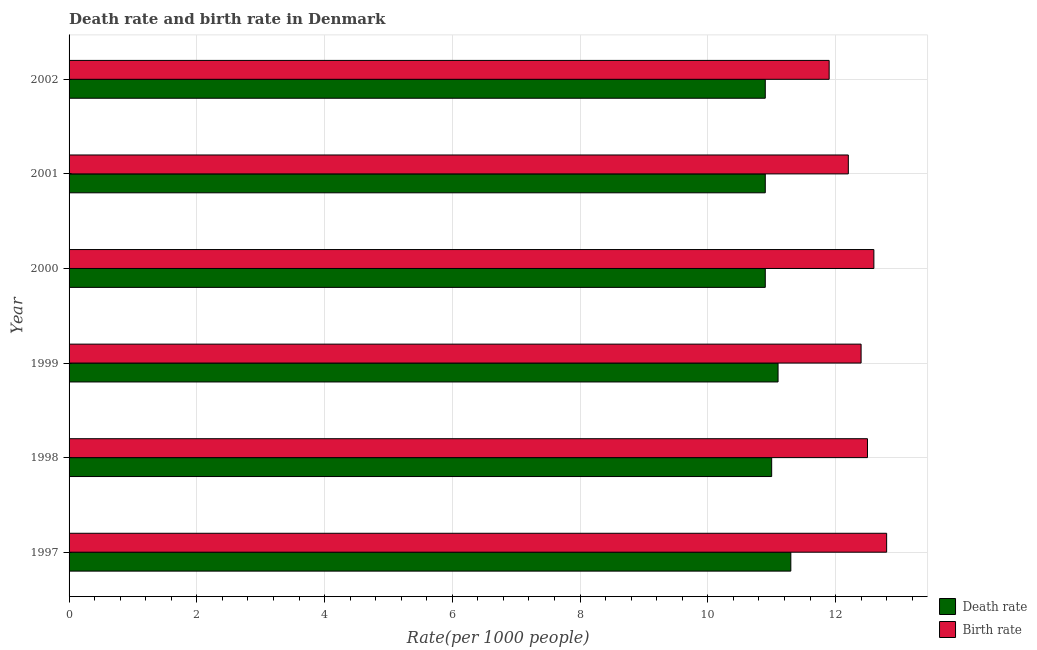How many different coloured bars are there?
Provide a succinct answer. 2. How many groups of bars are there?
Your response must be concise. 6. How many bars are there on the 4th tick from the top?
Give a very brief answer. 2. How many bars are there on the 2nd tick from the bottom?
Ensure brevity in your answer.  2. What is the birth rate in 2002?
Ensure brevity in your answer.  11.9. Across all years, what is the minimum death rate?
Provide a short and direct response. 10.9. In which year was the death rate maximum?
Keep it short and to the point. 1997. In which year was the birth rate minimum?
Ensure brevity in your answer.  2002. What is the total birth rate in the graph?
Ensure brevity in your answer.  74.4. What is the difference between the death rate in 1999 and the birth rate in 2001?
Ensure brevity in your answer.  -1.1. What is the average birth rate per year?
Your response must be concise. 12.4. In the year 2000, what is the difference between the birth rate and death rate?
Your answer should be very brief. 1.7. In how many years, is the death rate greater than 3.2 ?
Provide a short and direct response. 6. Is the death rate in 1999 less than that in 2002?
Provide a short and direct response. No. Is the difference between the death rate in 1999 and 2002 greater than the difference between the birth rate in 1999 and 2002?
Offer a terse response. No. What is the difference between the highest and the second highest birth rate?
Ensure brevity in your answer.  0.2. What does the 2nd bar from the top in 2001 represents?
Your response must be concise. Death rate. What does the 2nd bar from the bottom in 1997 represents?
Keep it short and to the point. Birth rate. How many bars are there?
Make the answer very short. 12. How many years are there in the graph?
Keep it short and to the point. 6. What is the difference between two consecutive major ticks on the X-axis?
Keep it short and to the point. 2. Are the values on the major ticks of X-axis written in scientific E-notation?
Keep it short and to the point. No. How are the legend labels stacked?
Your answer should be compact. Vertical. What is the title of the graph?
Give a very brief answer. Death rate and birth rate in Denmark. Does "Investment in Telecom" appear as one of the legend labels in the graph?
Provide a succinct answer. No. What is the label or title of the X-axis?
Provide a succinct answer. Rate(per 1000 people). What is the Rate(per 1000 people) in Birth rate in 1997?
Give a very brief answer. 12.8. What is the Rate(per 1000 people) of Death rate in 2000?
Offer a terse response. 10.9. What is the Rate(per 1000 people) in Death rate in 2001?
Offer a terse response. 10.9. What is the Rate(per 1000 people) of Birth rate in 2001?
Provide a short and direct response. 12.2. What is the Rate(per 1000 people) in Death rate in 2002?
Keep it short and to the point. 10.9. Across all years, what is the minimum Rate(per 1000 people) in Death rate?
Offer a very short reply. 10.9. What is the total Rate(per 1000 people) in Death rate in the graph?
Provide a succinct answer. 66.1. What is the total Rate(per 1000 people) in Birth rate in the graph?
Offer a very short reply. 74.4. What is the difference between the Rate(per 1000 people) of Birth rate in 1997 and that in 1998?
Your answer should be compact. 0.3. What is the difference between the Rate(per 1000 people) of Death rate in 1997 and that in 1999?
Give a very brief answer. 0.2. What is the difference between the Rate(per 1000 people) of Birth rate in 1997 and that in 1999?
Your response must be concise. 0.4. What is the difference between the Rate(per 1000 people) of Death rate in 1997 and that in 2001?
Keep it short and to the point. 0.4. What is the difference between the Rate(per 1000 people) in Birth rate in 1997 and that in 2001?
Your response must be concise. 0.6. What is the difference between the Rate(per 1000 people) in Death rate in 1997 and that in 2002?
Provide a short and direct response. 0.4. What is the difference between the Rate(per 1000 people) of Death rate in 1998 and that in 2000?
Provide a short and direct response. 0.1. What is the difference between the Rate(per 1000 people) of Death rate in 1998 and that in 2001?
Provide a succinct answer. 0.1. What is the difference between the Rate(per 1000 people) of Birth rate in 1998 and that in 2001?
Offer a very short reply. 0.3. What is the difference between the Rate(per 1000 people) of Death rate in 1998 and that in 2002?
Your answer should be very brief. 0.1. What is the difference between the Rate(per 1000 people) in Birth rate in 1998 and that in 2002?
Offer a terse response. 0.6. What is the difference between the Rate(per 1000 people) in Birth rate in 1999 and that in 2000?
Provide a short and direct response. -0.2. What is the difference between the Rate(per 1000 people) in Death rate in 1999 and that in 2001?
Keep it short and to the point. 0.2. What is the difference between the Rate(per 1000 people) in Death rate in 1999 and that in 2002?
Provide a succinct answer. 0.2. What is the difference between the Rate(per 1000 people) in Death rate in 2000 and that in 2001?
Provide a short and direct response. 0. What is the difference between the Rate(per 1000 people) of Birth rate in 2000 and that in 2002?
Your response must be concise. 0.7. What is the difference between the Rate(per 1000 people) in Death rate in 2001 and that in 2002?
Give a very brief answer. 0. What is the difference between the Rate(per 1000 people) in Birth rate in 2001 and that in 2002?
Ensure brevity in your answer.  0.3. What is the difference between the Rate(per 1000 people) of Death rate in 1997 and the Rate(per 1000 people) of Birth rate in 2000?
Ensure brevity in your answer.  -1.3. What is the difference between the Rate(per 1000 people) of Death rate in 1997 and the Rate(per 1000 people) of Birth rate in 2001?
Offer a very short reply. -0.9. What is the difference between the Rate(per 1000 people) in Death rate in 1997 and the Rate(per 1000 people) in Birth rate in 2002?
Provide a succinct answer. -0.6. What is the difference between the Rate(per 1000 people) of Death rate in 1998 and the Rate(per 1000 people) of Birth rate in 2000?
Offer a terse response. -1.6. What is the difference between the Rate(per 1000 people) of Death rate in 1998 and the Rate(per 1000 people) of Birth rate in 2001?
Offer a terse response. -1.2. What is the difference between the Rate(per 1000 people) in Death rate in 1999 and the Rate(per 1000 people) in Birth rate in 2000?
Your response must be concise. -1.5. What is the difference between the Rate(per 1000 people) in Death rate in 2000 and the Rate(per 1000 people) in Birth rate in 2001?
Your response must be concise. -1.3. What is the difference between the Rate(per 1000 people) in Death rate in 2000 and the Rate(per 1000 people) in Birth rate in 2002?
Keep it short and to the point. -1. What is the average Rate(per 1000 people) in Death rate per year?
Offer a terse response. 11.02. In the year 1997, what is the difference between the Rate(per 1000 people) in Death rate and Rate(per 1000 people) in Birth rate?
Your answer should be compact. -1.5. In the year 1998, what is the difference between the Rate(per 1000 people) in Death rate and Rate(per 1000 people) in Birth rate?
Keep it short and to the point. -1.5. In the year 1999, what is the difference between the Rate(per 1000 people) in Death rate and Rate(per 1000 people) in Birth rate?
Provide a short and direct response. -1.3. In the year 2000, what is the difference between the Rate(per 1000 people) of Death rate and Rate(per 1000 people) of Birth rate?
Provide a succinct answer. -1.7. In the year 2002, what is the difference between the Rate(per 1000 people) in Death rate and Rate(per 1000 people) in Birth rate?
Provide a short and direct response. -1. What is the ratio of the Rate(per 1000 people) in Death rate in 1997 to that in 1998?
Make the answer very short. 1.03. What is the ratio of the Rate(per 1000 people) of Birth rate in 1997 to that in 1998?
Offer a terse response. 1.02. What is the ratio of the Rate(per 1000 people) in Birth rate in 1997 to that in 1999?
Provide a succinct answer. 1.03. What is the ratio of the Rate(per 1000 people) in Death rate in 1997 to that in 2000?
Give a very brief answer. 1.04. What is the ratio of the Rate(per 1000 people) in Birth rate in 1997 to that in 2000?
Offer a terse response. 1.02. What is the ratio of the Rate(per 1000 people) of Death rate in 1997 to that in 2001?
Offer a terse response. 1.04. What is the ratio of the Rate(per 1000 people) in Birth rate in 1997 to that in 2001?
Your answer should be very brief. 1.05. What is the ratio of the Rate(per 1000 people) in Death rate in 1997 to that in 2002?
Provide a succinct answer. 1.04. What is the ratio of the Rate(per 1000 people) in Birth rate in 1997 to that in 2002?
Keep it short and to the point. 1.08. What is the ratio of the Rate(per 1000 people) in Death rate in 1998 to that in 1999?
Give a very brief answer. 0.99. What is the ratio of the Rate(per 1000 people) in Birth rate in 1998 to that in 1999?
Offer a terse response. 1.01. What is the ratio of the Rate(per 1000 people) of Death rate in 1998 to that in 2000?
Offer a very short reply. 1.01. What is the ratio of the Rate(per 1000 people) in Death rate in 1998 to that in 2001?
Offer a terse response. 1.01. What is the ratio of the Rate(per 1000 people) of Birth rate in 1998 to that in 2001?
Give a very brief answer. 1.02. What is the ratio of the Rate(per 1000 people) of Death rate in 1998 to that in 2002?
Your answer should be very brief. 1.01. What is the ratio of the Rate(per 1000 people) in Birth rate in 1998 to that in 2002?
Your response must be concise. 1.05. What is the ratio of the Rate(per 1000 people) of Death rate in 1999 to that in 2000?
Make the answer very short. 1.02. What is the ratio of the Rate(per 1000 people) in Birth rate in 1999 to that in 2000?
Provide a succinct answer. 0.98. What is the ratio of the Rate(per 1000 people) in Death rate in 1999 to that in 2001?
Your answer should be very brief. 1.02. What is the ratio of the Rate(per 1000 people) of Birth rate in 1999 to that in 2001?
Provide a succinct answer. 1.02. What is the ratio of the Rate(per 1000 people) of Death rate in 1999 to that in 2002?
Ensure brevity in your answer.  1.02. What is the ratio of the Rate(per 1000 people) in Birth rate in 1999 to that in 2002?
Make the answer very short. 1.04. What is the ratio of the Rate(per 1000 people) in Birth rate in 2000 to that in 2001?
Give a very brief answer. 1.03. What is the ratio of the Rate(per 1000 people) in Death rate in 2000 to that in 2002?
Offer a very short reply. 1. What is the ratio of the Rate(per 1000 people) of Birth rate in 2000 to that in 2002?
Provide a short and direct response. 1.06. What is the ratio of the Rate(per 1000 people) of Birth rate in 2001 to that in 2002?
Provide a short and direct response. 1.03. What is the difference between the highest and the second highest Rate(per 1000 people) of Birth rate?
Your answer should be compact. 0.2. What is the difference between the highest and the lowest Rate(per 1000 people) of Death rate?
Give a very brief answer. 0.4. 